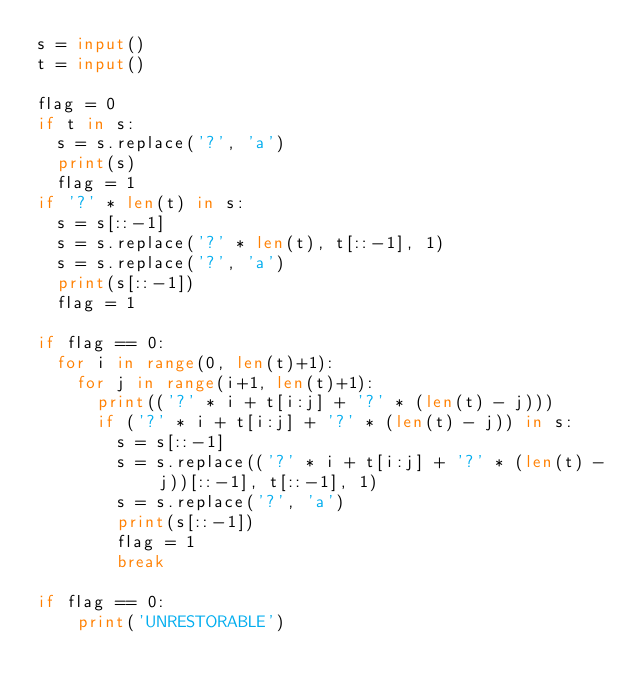Convert code to text. <code><loc_0><loc_0><loc_500><loc_500><_Python_>s = input()
t = input()

flag = 0
if t in s:
  s = s.replace('?', 'a')
  print(s)
  flag = 1
if '?' * len(t) in s:
  s = s[::-1]
  s = s.replace('?' * len(t), t[::-1], 1)
  s = s.replace('?', 'a')
  print(s[::-1])
  flag = 1          

if flag == 0:
  for i in range(0, len(t)+1):
    for j in range(i+1, len(t)+1):
      print(('?' * i + t[i:j] + '?' * (len(t) - j)))
      if ('?' * i + t[i:j] + '?' * (len(t) - j)) in s:
        s = s[::-1]
        s = s.replace(('?' * i + t[i:j] + '?' * (len(t) - j))[::-1], t[::-1], 1)
        s = s.replace('?', 'a')
        print(s[::-1])
        flag = 1
        break
    
if flag == 0:
	print('UNRESTORABLE')</code> 